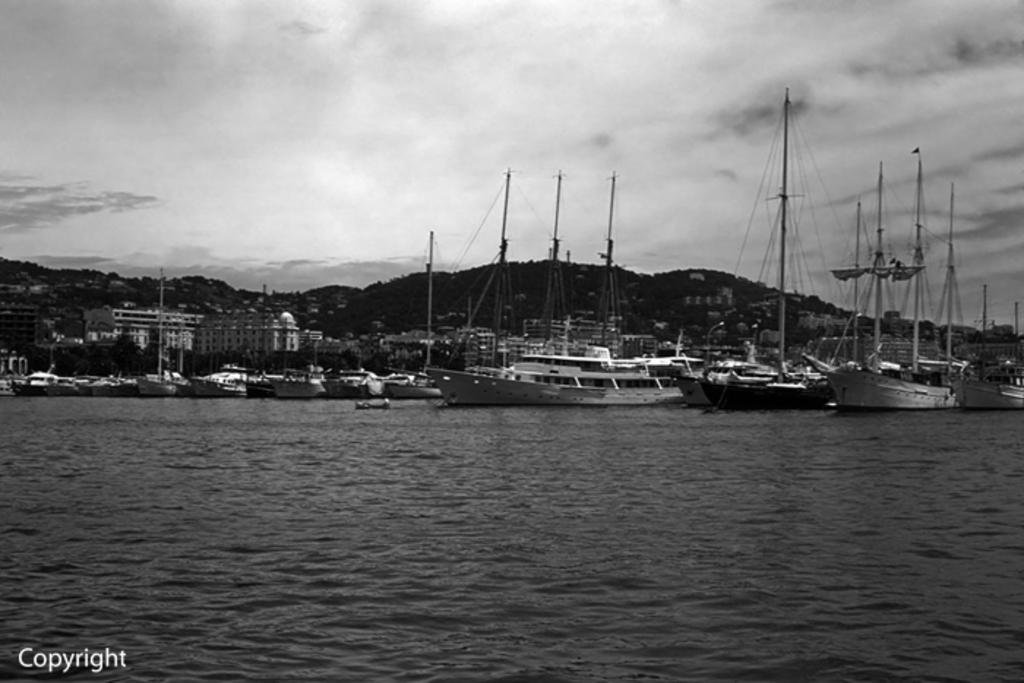What is the color scheme of the image? The image is black and white. What is the main subject on the water surface in the image? There are ships on the water surface in the image. What can be seen in the background of the image? There are buildings and mountains in the background of the image. Can you see a patch of grass near the ships in the image? There is no grass visible in the image; it features a water surface with ships and a background of buildings and mountains. 